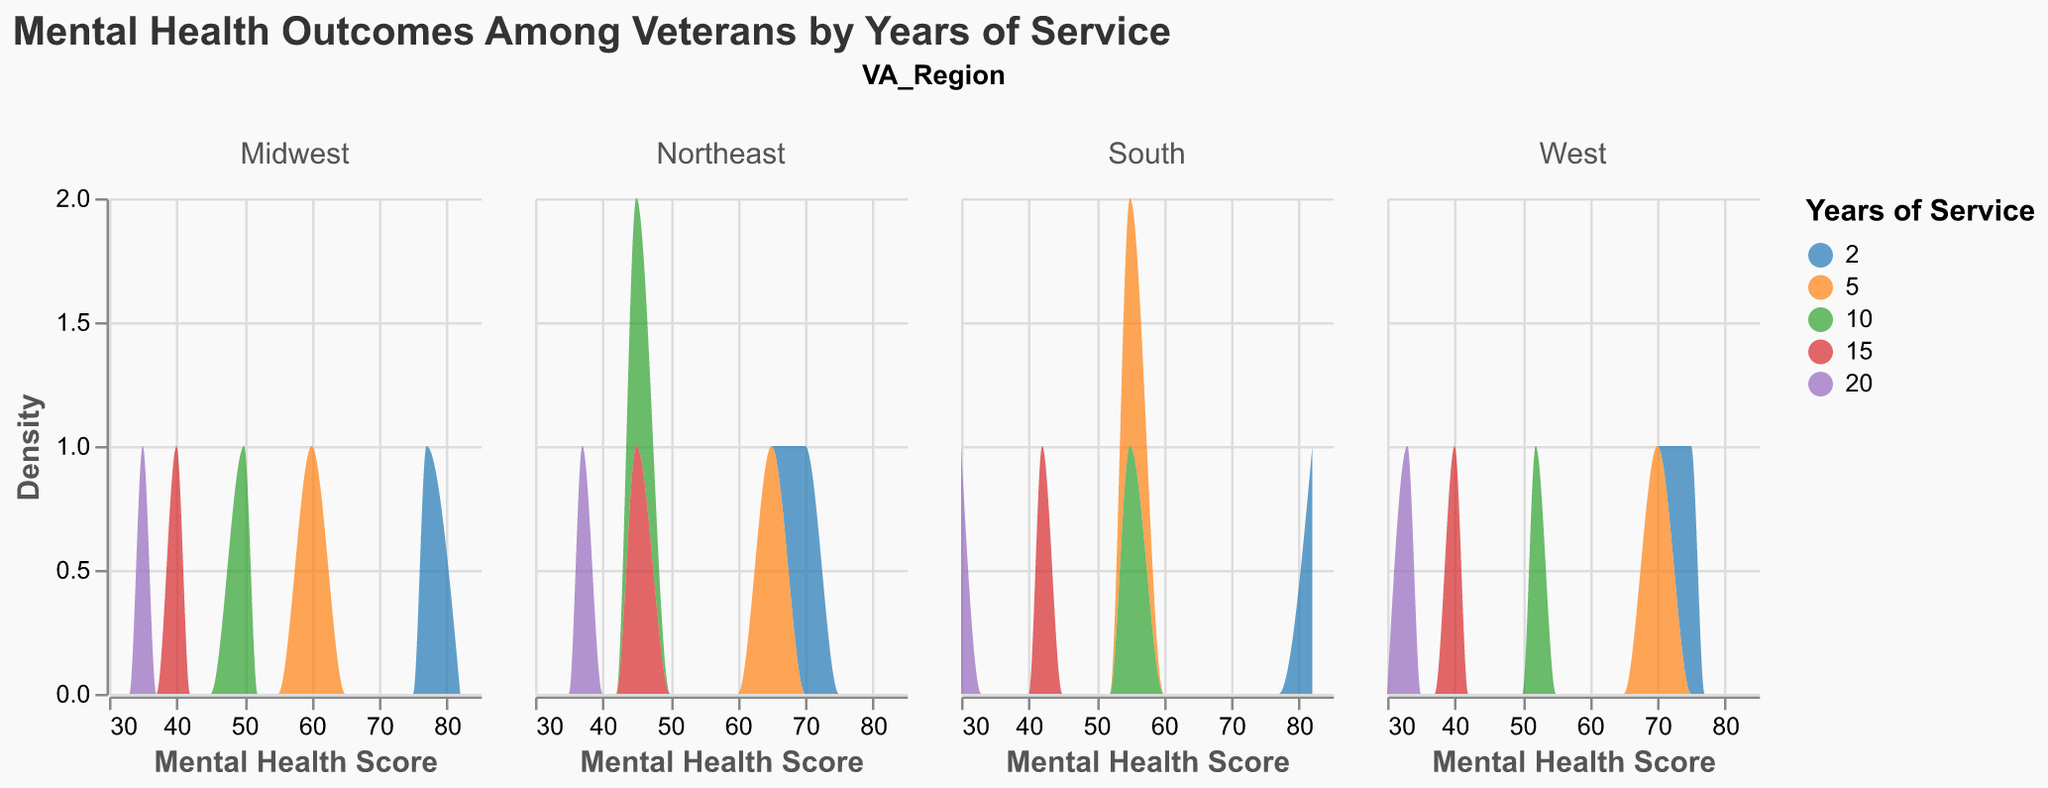What is the title of the plot? The title is positioned at the top of the plot and reads "Mental Health Outcomes Among Veterans by Years of Service."
Answer: Mental Health Outcomes Among Veterans by Years of Service How many VA regions are represented in the plot? The plot shows four columns, each representing a different VA region: "Northeast," "Midwest," "South," and "West."
Answer: Four Which VA region has the highest density for veterans with 2 years of service? We need to look at the density plots for veterans with 2 years of service and compare them across different regions. The highest density for 2 years of service appears to be in the South region.
Answer: South How does the mental health score distribution for 15 years of service compare between the Northeast and Midwest regions? By comparing the density plots for 15 years of service between the Northeast and Midwest regions, we observe that the Midwest region has a lower peak density and covers a generally lower mental health score range compared to the Northeast.
Answer: Northeast is higher What range of mental health scores is most common for veterans with 10 years of service in the West region? Look at the density plot for veterans with 10 years of service in the West region. The plot peaks around the mental health scores of 50-55, indicating this is the most common range.
Answer: 50-55 In the South region, what can you say about the density of veterans with 5 years and 20 years of service? Examine the density plots in the South region for both 5 years and 20 years of service. The plot shows that the density of veterans with 5 years of service is higher and peaks at a higher mental health score compared to those with 20 years of service.
Answer: 5 years is higher Which region exhibits the most variance in mental health scores for veterans with 2 years of service? Assess the width of the density plots for veterans with 2 years of service across all regions. The South region shows the widest spread in scores, indicating the most variance.
Answer: South What could be inferred about mental health scores as years of service increase? Observe the trend across all regions; mental health scores generally decrease as years of service increase. Each subsequent density plot for higher years of service peaks at a lower score.
Answer: Scores decrease Comparatively, which VA region shows the best overall mental health outcomes for veterans across all years of service? Consider the density plots across each VA region and observe the mental health scores. The Midwest and West regions appear to have higher mental health scores more consistently across various years of service.
Answer: Midwest and West 